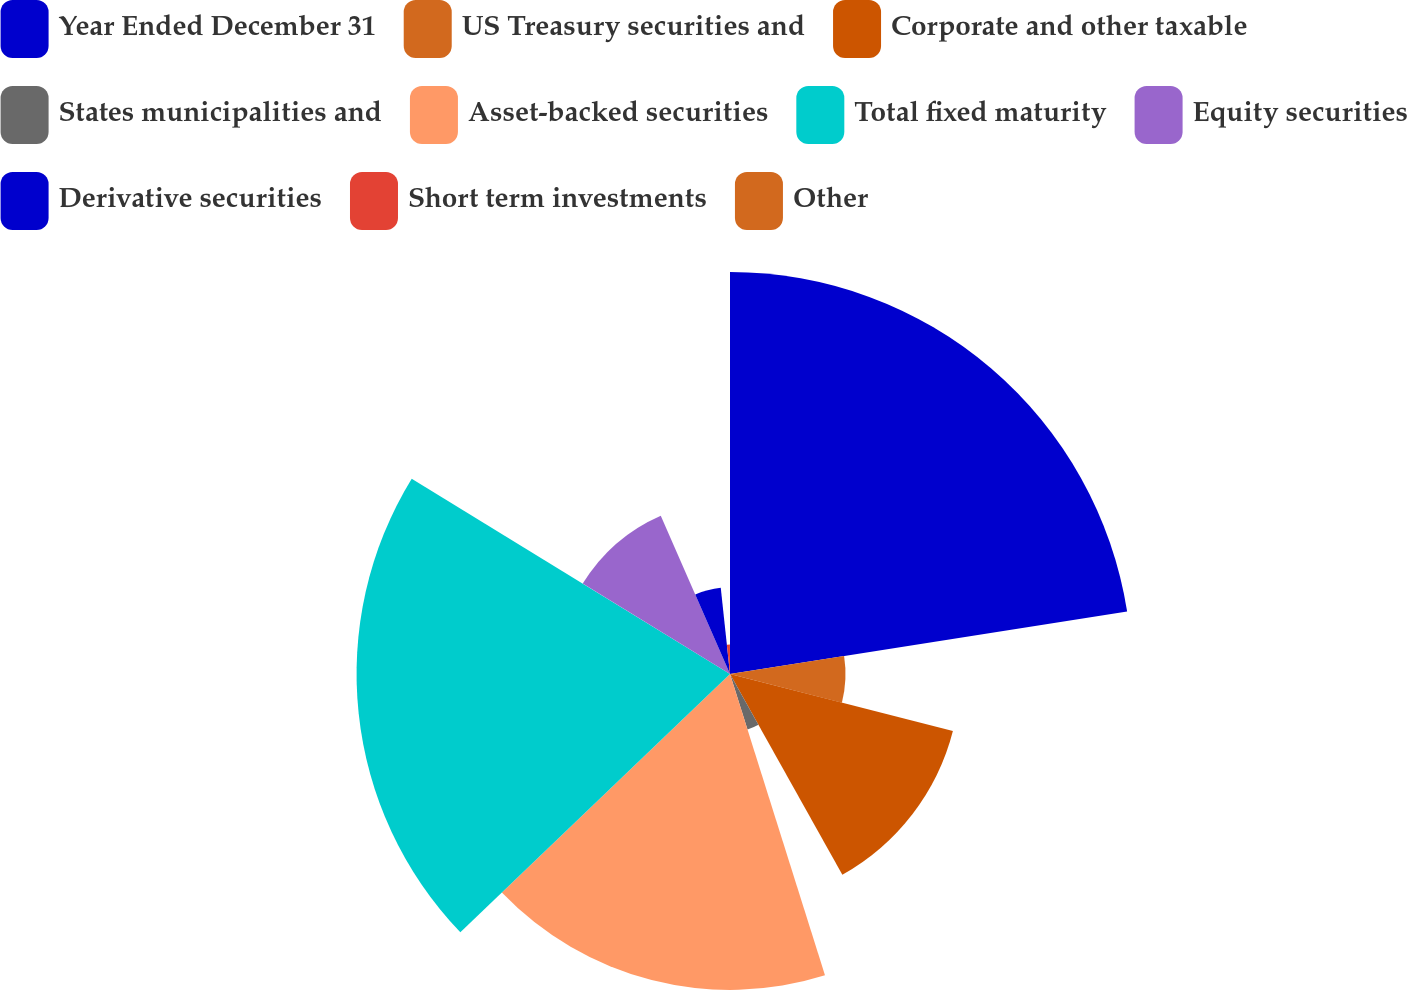Convert chart to OTSL. <chart><loc_0><loc_0><loc_500><loc_500><pie_chart><fcel>Year Ended December 31<fcel>US Treasury securities and<fcel>Corporate and other taxable<fcel>States municipalities and<fcel>Asset-backed securities<fcel>Total fixed maturity<fcel>Equity securities<fcel>Derivative securities<fcel>Short term investments<fcel>Other<nl><fcel>22.52%<fcel>6.47%<fcel>12.89%<fcel>3.26%<fcel>17.7%<fcel>20.92%<fcel>9.68%<fcel>4.86%<fcel>1.65%<fcel>0.05%<nl></chart> 